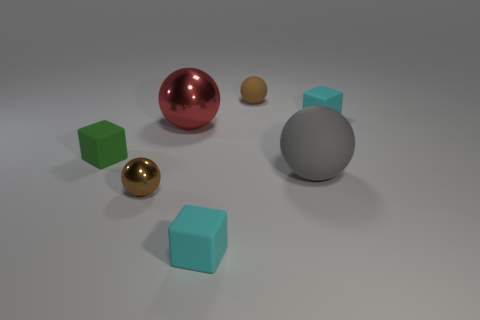There is a ball that is the same color as the small metallic object; what material is it?
Offer a terse response. Rubber. Do the brown rubber object and the small green rubber thing have the same shape?
Provide a short and direct response. No. Is the material of the tiny cyan thing that is in front of the gray object the same as the gray thing?
Offer a very short reply. Yes. Is the big sphere that is on the left side of the tiny matte ball made of the same material as the small brown object that is behind the small metal thing?
Provide a succinct answer. No. Is the number of metallic objects on the right side of the gray matte ball greater than the number of rubber spheres?
Ensure brevity in your answer.  No. The large shiny sphere that is behind the small object to the left of the small metallic thing is what color?
Offer a very short reply. Red. The metal object that is the same size as the green matte object is what shape?
Provide a short and direct response. Sphere. What is the shape of the small shiny object that is the same color as the small matte ball?
Give a very brief answer. Sphere. Are there the same number of brown things that are left of the large red metallic sphere and gray rubber objects?
Your answer should be compact. Yes. What is the material of the tiny cyan object on the left side of the small matte thing to the right of the rubber sphere that is in front of the tiny brown matte sphere?
Keep it short and to the point. Rubber. 